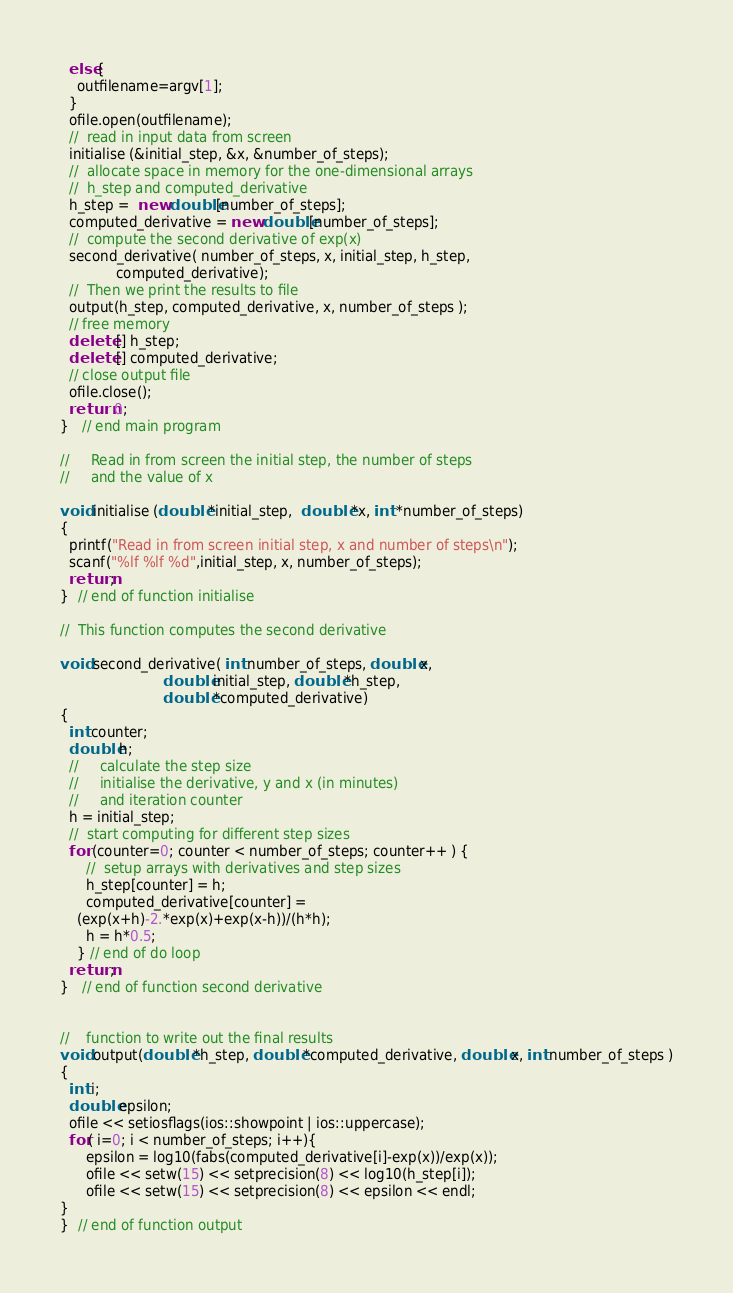<code> <loc_0><loc_0><loc_500><loc_500><_C++_>  else{
    outfilename=argv[1];
  }
  ofile.open(outfilename);
  //  read in input data from screen 
  initialise (&initial_step, &x, &number_of_steps);
  //  allocate space in memory for the one-dimensional arrays  
  //  h_step and computed_derivative                           
  h_step =  new double[number_of_steps];
  computed_derivative = new double[number_of_steps];
  //  compute the second derivative of exp(x) 
  second_derivative( number_of_steps, x, initial_step, h_step, 
		     computed_derivative);        
  //  Then we print the results to file  
  output(h_step, computed_derivative, x, number_of_steps );
  // free memory
  delete [] h_step;
  delete [] computed_derivative; 
  // close output file
  ofile.close();
  return 0;
}   // end main program 

//     Read in from screen the initial step, the number of steps 
//     and the value of x 

void initialise (double *initial_step,  double *x, int *number_of_steps)
{
  printf("Read in from screen initial step, x and number of steps\n");
  scanf("%lf %lf %d",initial_step, x, number_of_steps);
  return;
}  // end of function initialise 

//  This function computes the second derivative 

void second_derivative( int number_of_steps, double x, 
                        double initial_step, double *h_step, 
                        double *computed_derivative)
{
  int counter;
  double h;
  //     calculate the step size  
  //     initialise the derivative, y and x (in minutes) 
  //     and iteration counter 
  h = initial_step;
  //  start computing for different step sizes 
  for (counter=0; counter < number_of_steps; counter++ ) {
      //  setup arrays with derivatives and step sizes
      h_step[counter] = h;
      computed_derivative[counter] = 
	(exp(x+h)-2.*exp(x)+exp(x-h))/(h*h);
      h = h*0.5;
    } // end of do loop 
  return;
}   // end of function second derivative 


//    function to write out the final results  
void output(double *h_step, double *computed_derivative, double x, int number_of_steps )
{
  int i;
  double epsilon;
  ofile << setiosflags(ios::showpoint | ios::uppercase);
  for( i=0; i < number_of_steps; i++){
      epsilon = log10(fabs(computed_derivative[i]-exp(x))/exp(x));      
      ofile << setw(15) << setprecision(8) << log10(h_step[i]);
      ofile << setw(15) << setprecision(8) << epsilon << endl;
}
}  // end of function output

</code> 